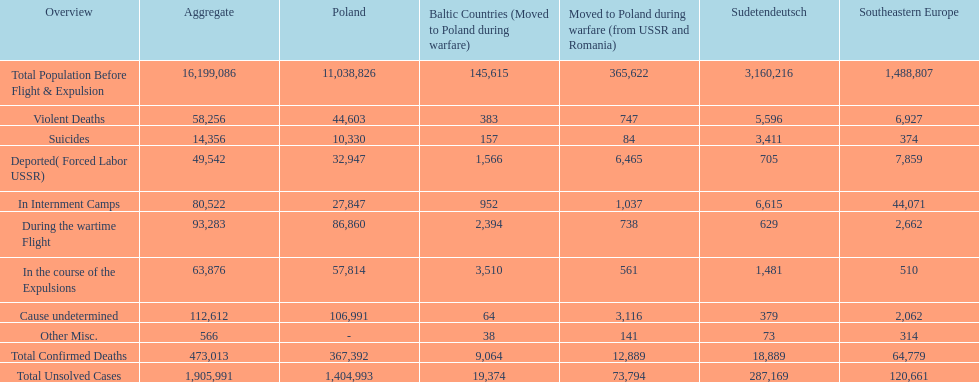Which country had the larger death tole? Poland. 